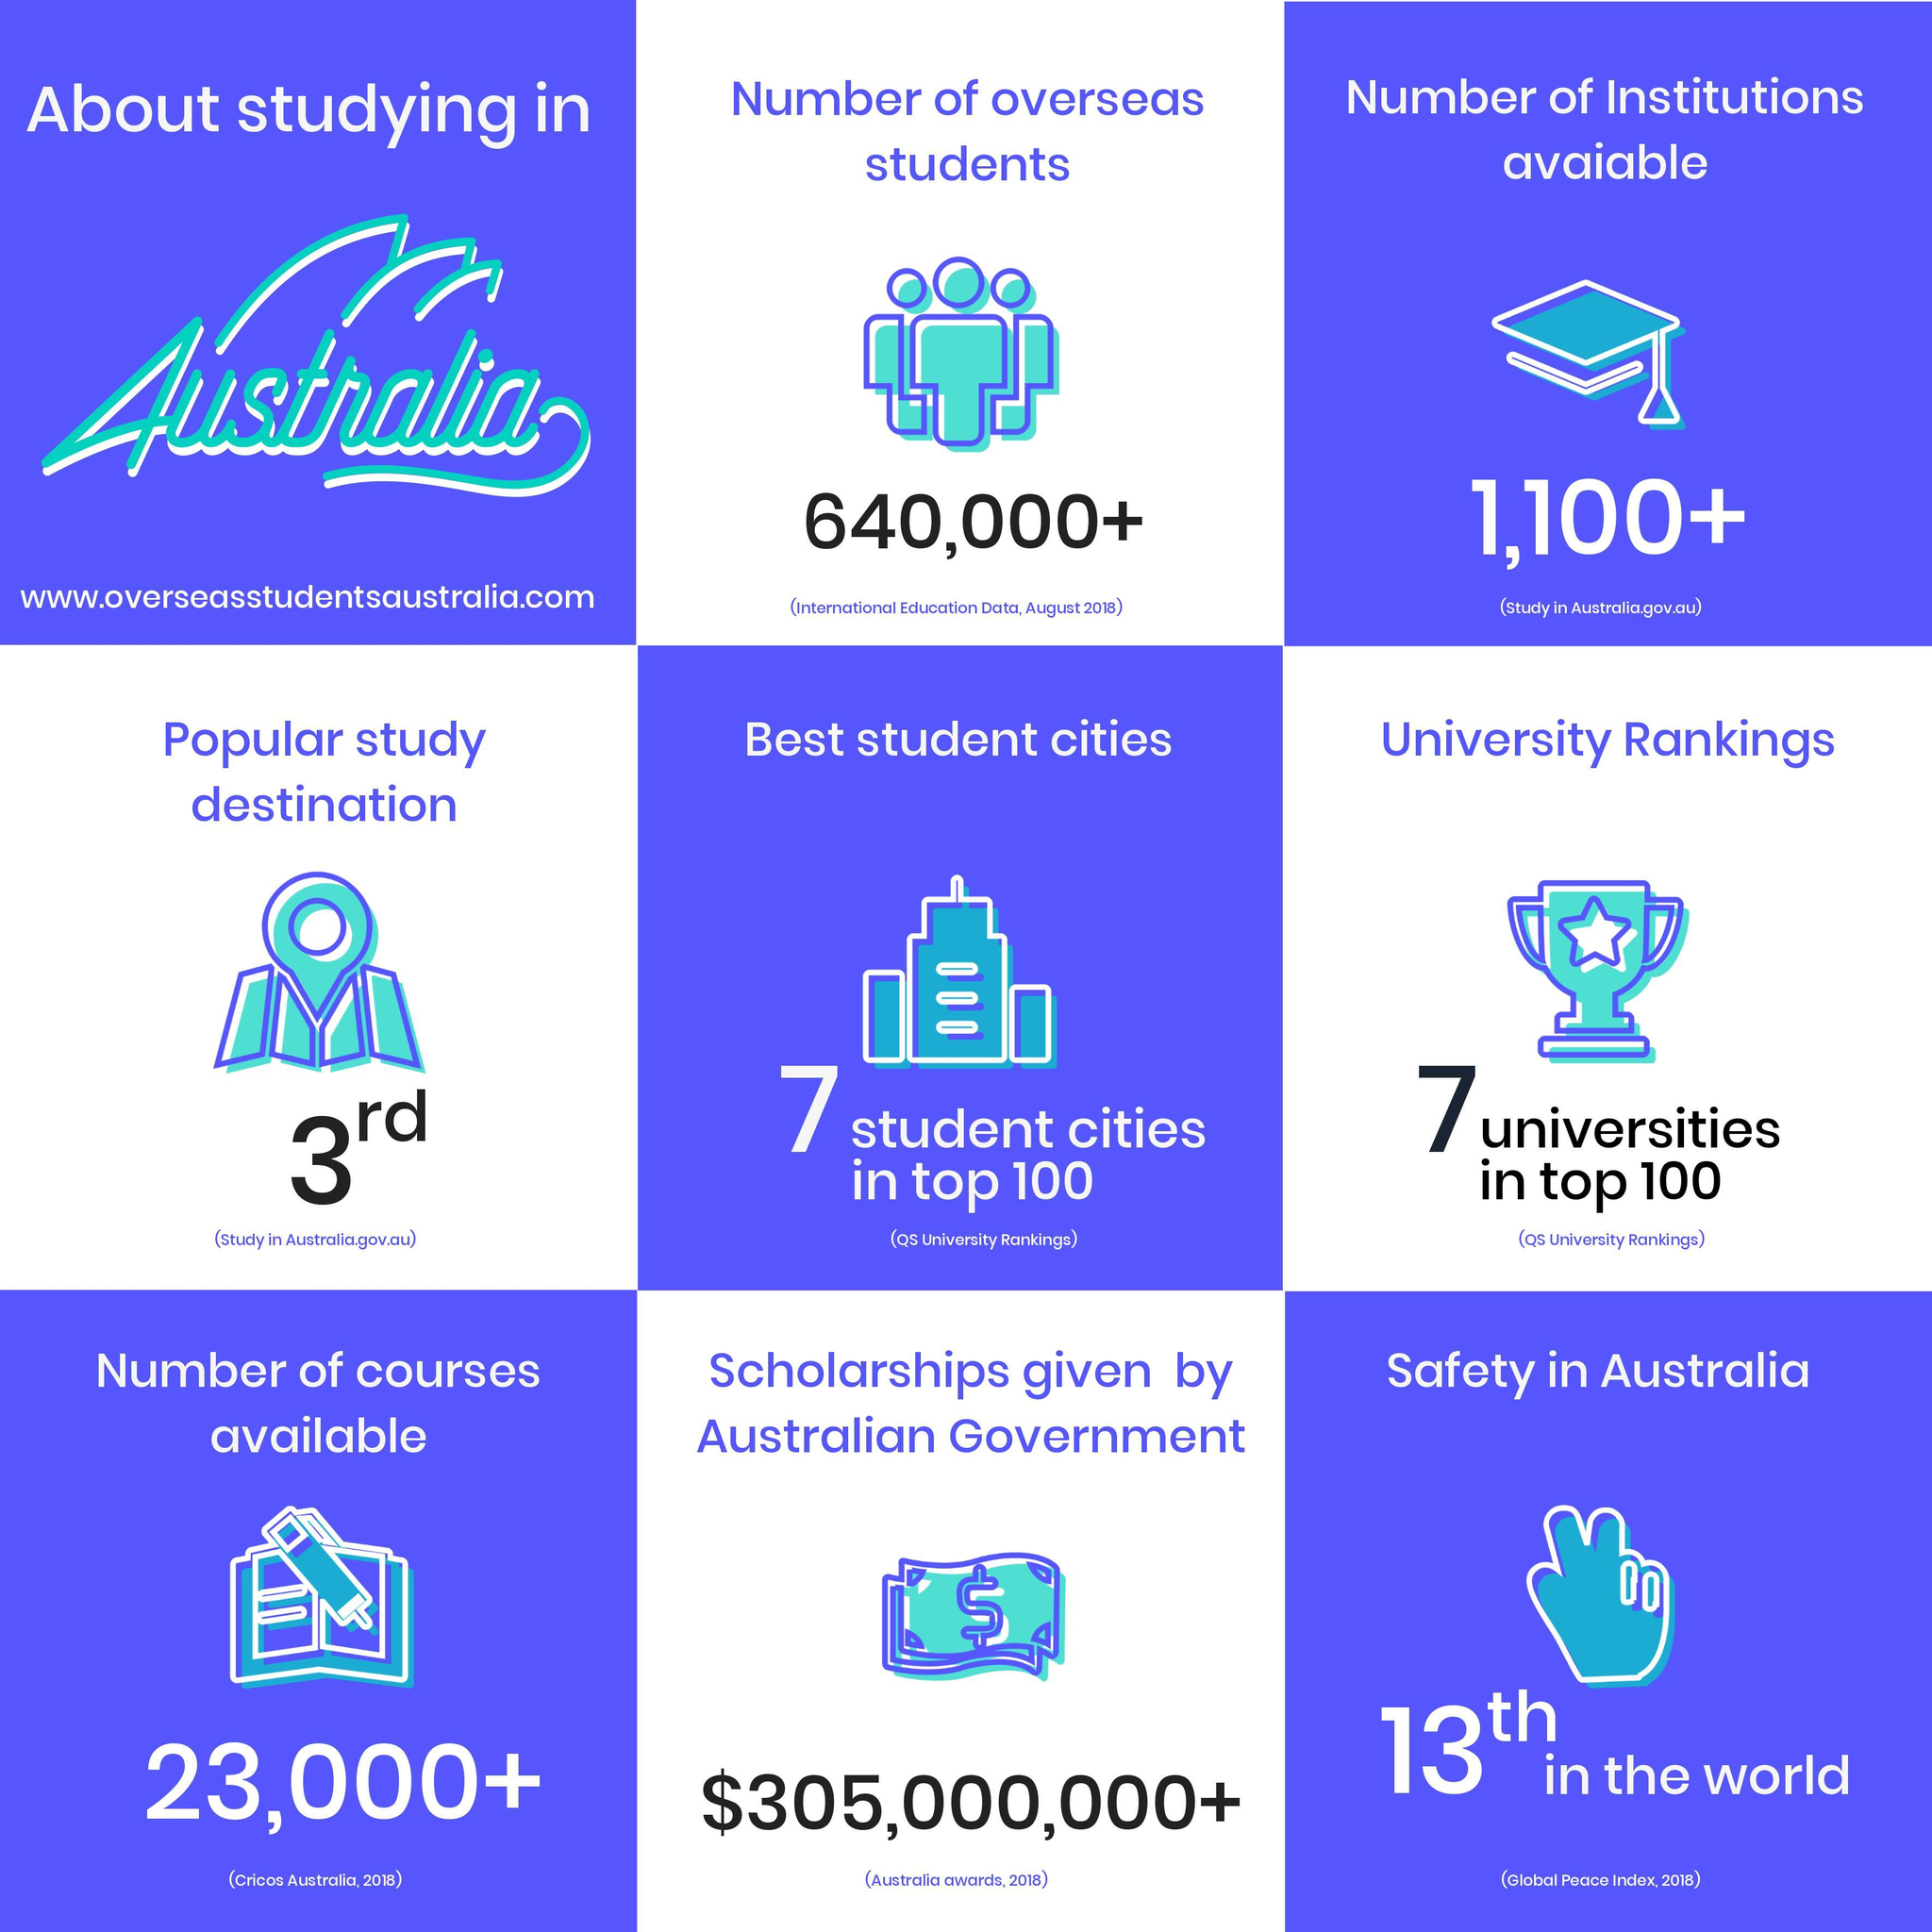How many different courses were available in Australia in 2018?
Answer the question with a short phrase. 23,000+ What is the number of institutions available in Australia? 1,100+ How many overseas students are studying in Australia as of August 2018? 640,000+ How many scholarships were given by the Australian government in 2018? $305,000,000+ 